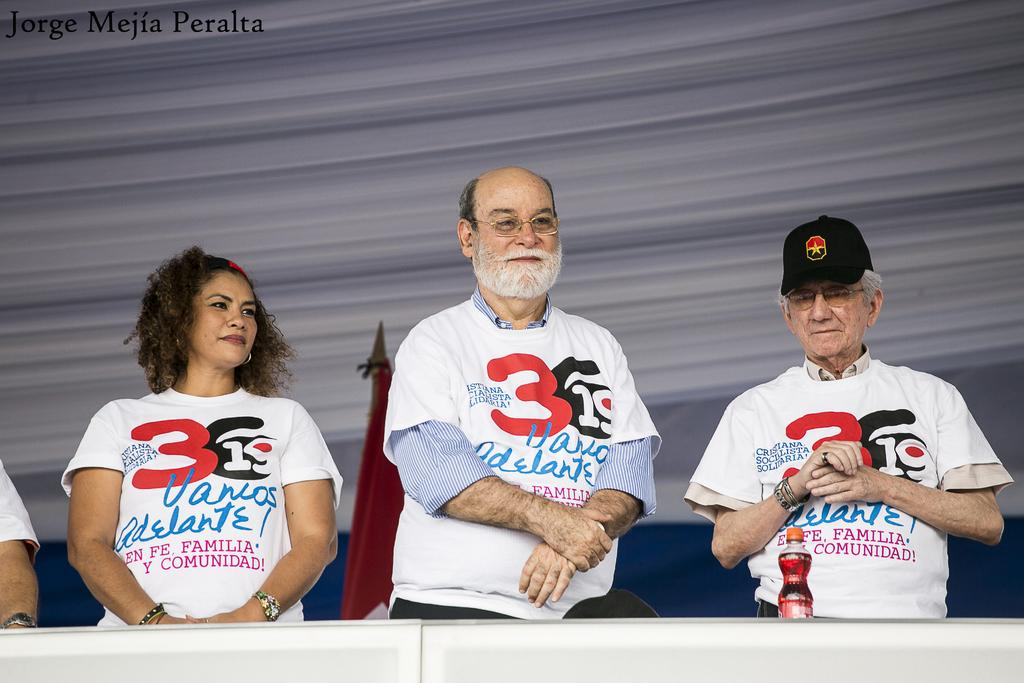<image>
Share a concise interpretation of the image provided. Jorge Mejia Peralta took a photograph of three people wearing white shirts. 